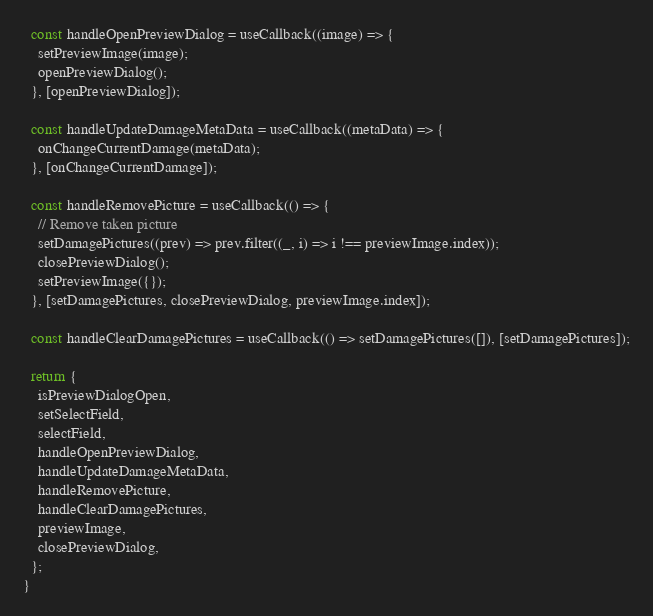<code> <loc_0><loc_0><loc_500><loc_500><_JavaScript_>
  const handleOpenPreviewDialog = useCallback((image) => {
    setPreviewImage(image);
    openPreviewDialog();
  }, [openPreviewDialog]);

  const handleUpdateDamageMetaData = useCallback((metaData) => {
    onChangeCurrentDamage(metaData);
  }, [onChangeCurrentDamage]);

  const handleRemovePicture = useCallback(() => {
    // Remove taken picture
    setDamagePictures((prev) => prev.filter((_, i) => i !== previewImage.index));
    closePreviewDialog();
    setPreviewImage({});
  }, [setDamagePictures, closePreviewDialog, previewImage.index]);

  const handleClearDamagePictures = useCallback(() => setDamagePictures([]), [setDamagePictures]);

  return {
    isPreviewDialogOpen,
    setSelectField,
    selectField,
    handleOpenPreviewDialog,
    handleUpdateDamageMetaData,
    handleRemovePicture,
    handleClearDamagePictures,
    previewImage,
    closePreviewDialog,
  };
}
</code> 